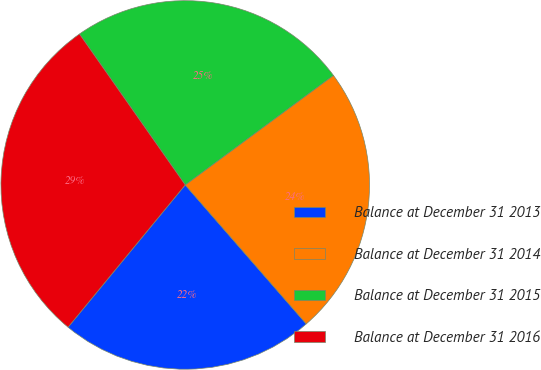Convert chart to OTSL. <chart><loc_0><loc_0><loc_500><loc_500><pie_chart><fcel>Balance at December 31 2013<fcel>Balance at December 31 2014<fcel>Balance at December 31 2015<fcel>Balance at December 31 2016<nl><fcel>22.37%<fcel>23.73%<fcel>24.6%<fcel>29.31%<nl></chart> 